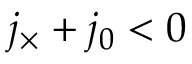<formula> <loc_0><loc_0><loc_500><loc_500>j _ { \times } + j _ { 0 } < 0</formula> 